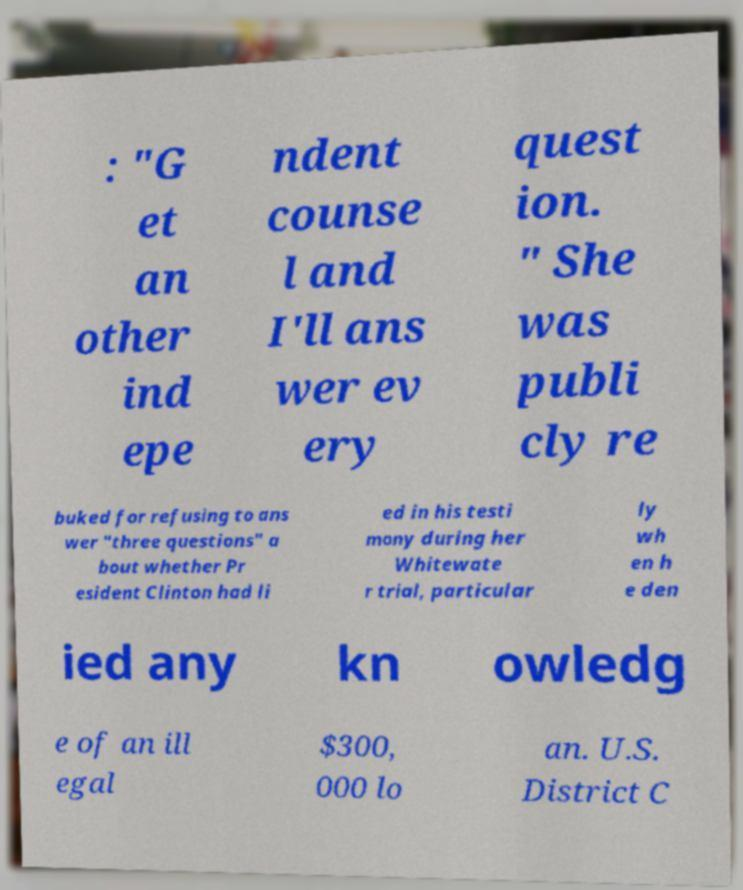Please read and relay the text visible in this image. What does it say? : "G et an other ind epe ndent counse l and I'll ans wer ev ery quest ion. " She was publi cly re buked for refusing to ans wer "three questions" a bout whether Pr esident Clinton had li ed in his testi mony during her Whitewate r trial, particular ly wh en h e den ied any kn owledg e of an ill egal $300, 000 lo an. U.S. District C 